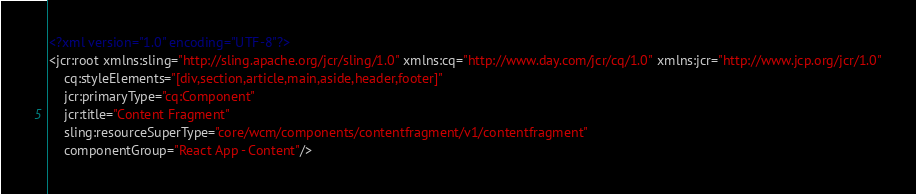<code> <loc_0><loc_0><loc_500><loc_500><_XML_><?xml version="1.0" encoding="UTF-8"?>
<jcr:root xmlns:sling="http://sling.apache.org/jcr/sling/1.0" xmlns:cq="http://www.day.com/jcr/cq/1.0" xmlns:jcr="http://www.jcp.org/jcr/1.0"
    cq:styleElements="[div,section,article,main,aside,header,footer]"
    jcr:primaryType="cq:Component"
    jcr:title="Content Fragment"
    sling:resourceSuperType="core/wcm/components/contentfragment/v1/contentfragment"
    componentGroup="React App - Content"/>
</code> 